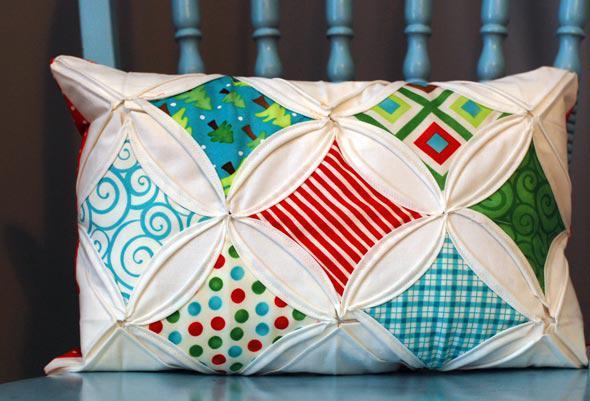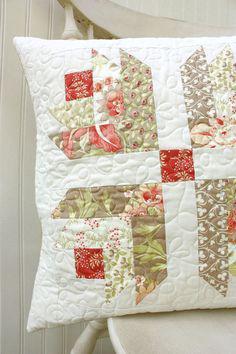The first image is the image on the left, the second image is the image on the right. For the images shown, is this caption "One pillow has a vertical stripe pattern." true? Answer yes or no. No. The first image is the image on the left, the second image is the image on the right. For the images shown, is this caption "The left and right image contains the same number of quilted piece of fabric." true? Answer yes or no. Yes. 